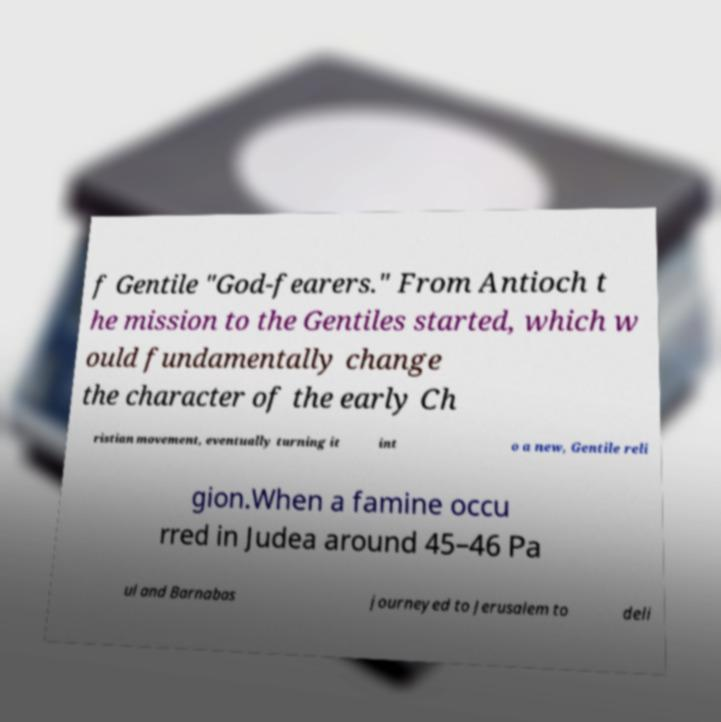For documentation purposes, I need the text within this image transcribed. Could you provide that? f Gentile "God-fearers." From Antioch t he mission to the Gentiles started, which w ould fundamentally change the character of the early Ch ristian movement, eventually turning it int o a new, Gentile reli gion.When a famine occu rred in Judea around 45–46 Pa ul and Barnabas journeyed to Jerusalem to deli 